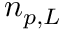Convert formula to latex. <formula><loc_0><loc_0><loc_500><loc_500>n _ { p , L }</formula> 